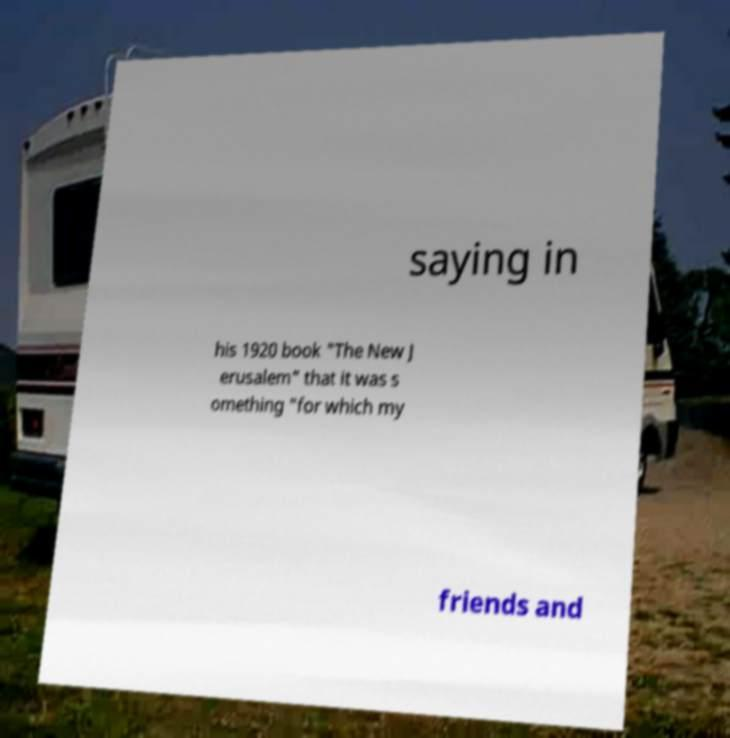What messages or text are displayed in this image? I need them in a readable, typed format. saying in his 1920 book "The New J erusalem" that it was s omething "for which my friends and 